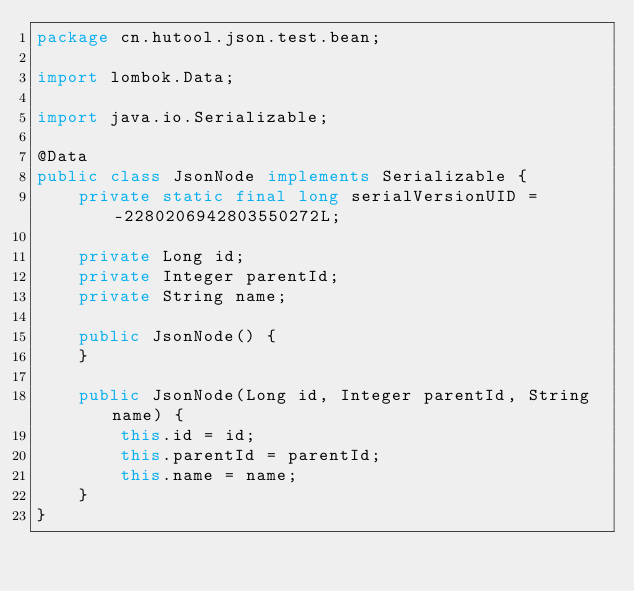Convert code to text. <code><loc_0><loc_0><loc_500><loc_500><_Java_>package cn.hutool.json.test.bean;

import lombok.Data;

import java.io.Serializable;

@Data
public class JsonNode implements Serializable {
	private static final long serialVersionUID = -2280206942803550272L;

	private Long id;
	private Integer parentId;
	private String name;

	public JsonNode() {
	}

	public JsonNode(Long id, Integer parentId, String name) {
		this.id = id;
		this.parentId = parentId;
		this.name = name;
	}
}
</code> 